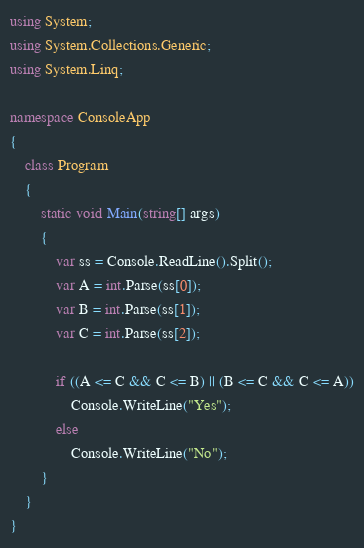<code> <loc_0><loc_0><loc_500><loc_500><_C#_>using System;
using System.Collections.Generic;
using System.Linq;

namespace ConsoleApp
{
    class Program
    {
        static void Main(string[] args)
        {
            var ss = Console.ReadLine().Split();
            var A = int.Parse(ss[0]);
            var B = int.Parse(ss[1]);
            var C = int.Parse(ss[2]);

            if ((A <= C && C <= B) || (B <= C && C <= A))
                Console.WriteLine("Yes");
            else
                Console.WriteLine("No");
        }
    }
}</code> 